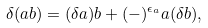Convert formula to latex. <formula><loc_0><loc_0><loc_500><loc_500>\delta ( a b ) = ( \delta a ) b + ( - ) ^ { \epsilon _ { a } } a ( \delta b ) ,</formula> 